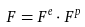Convert formula to latex. <formula><loc_0><loc_0><loc_500><loc_500>F = F ^ { e } \cdot F ^ { p }</formula> 